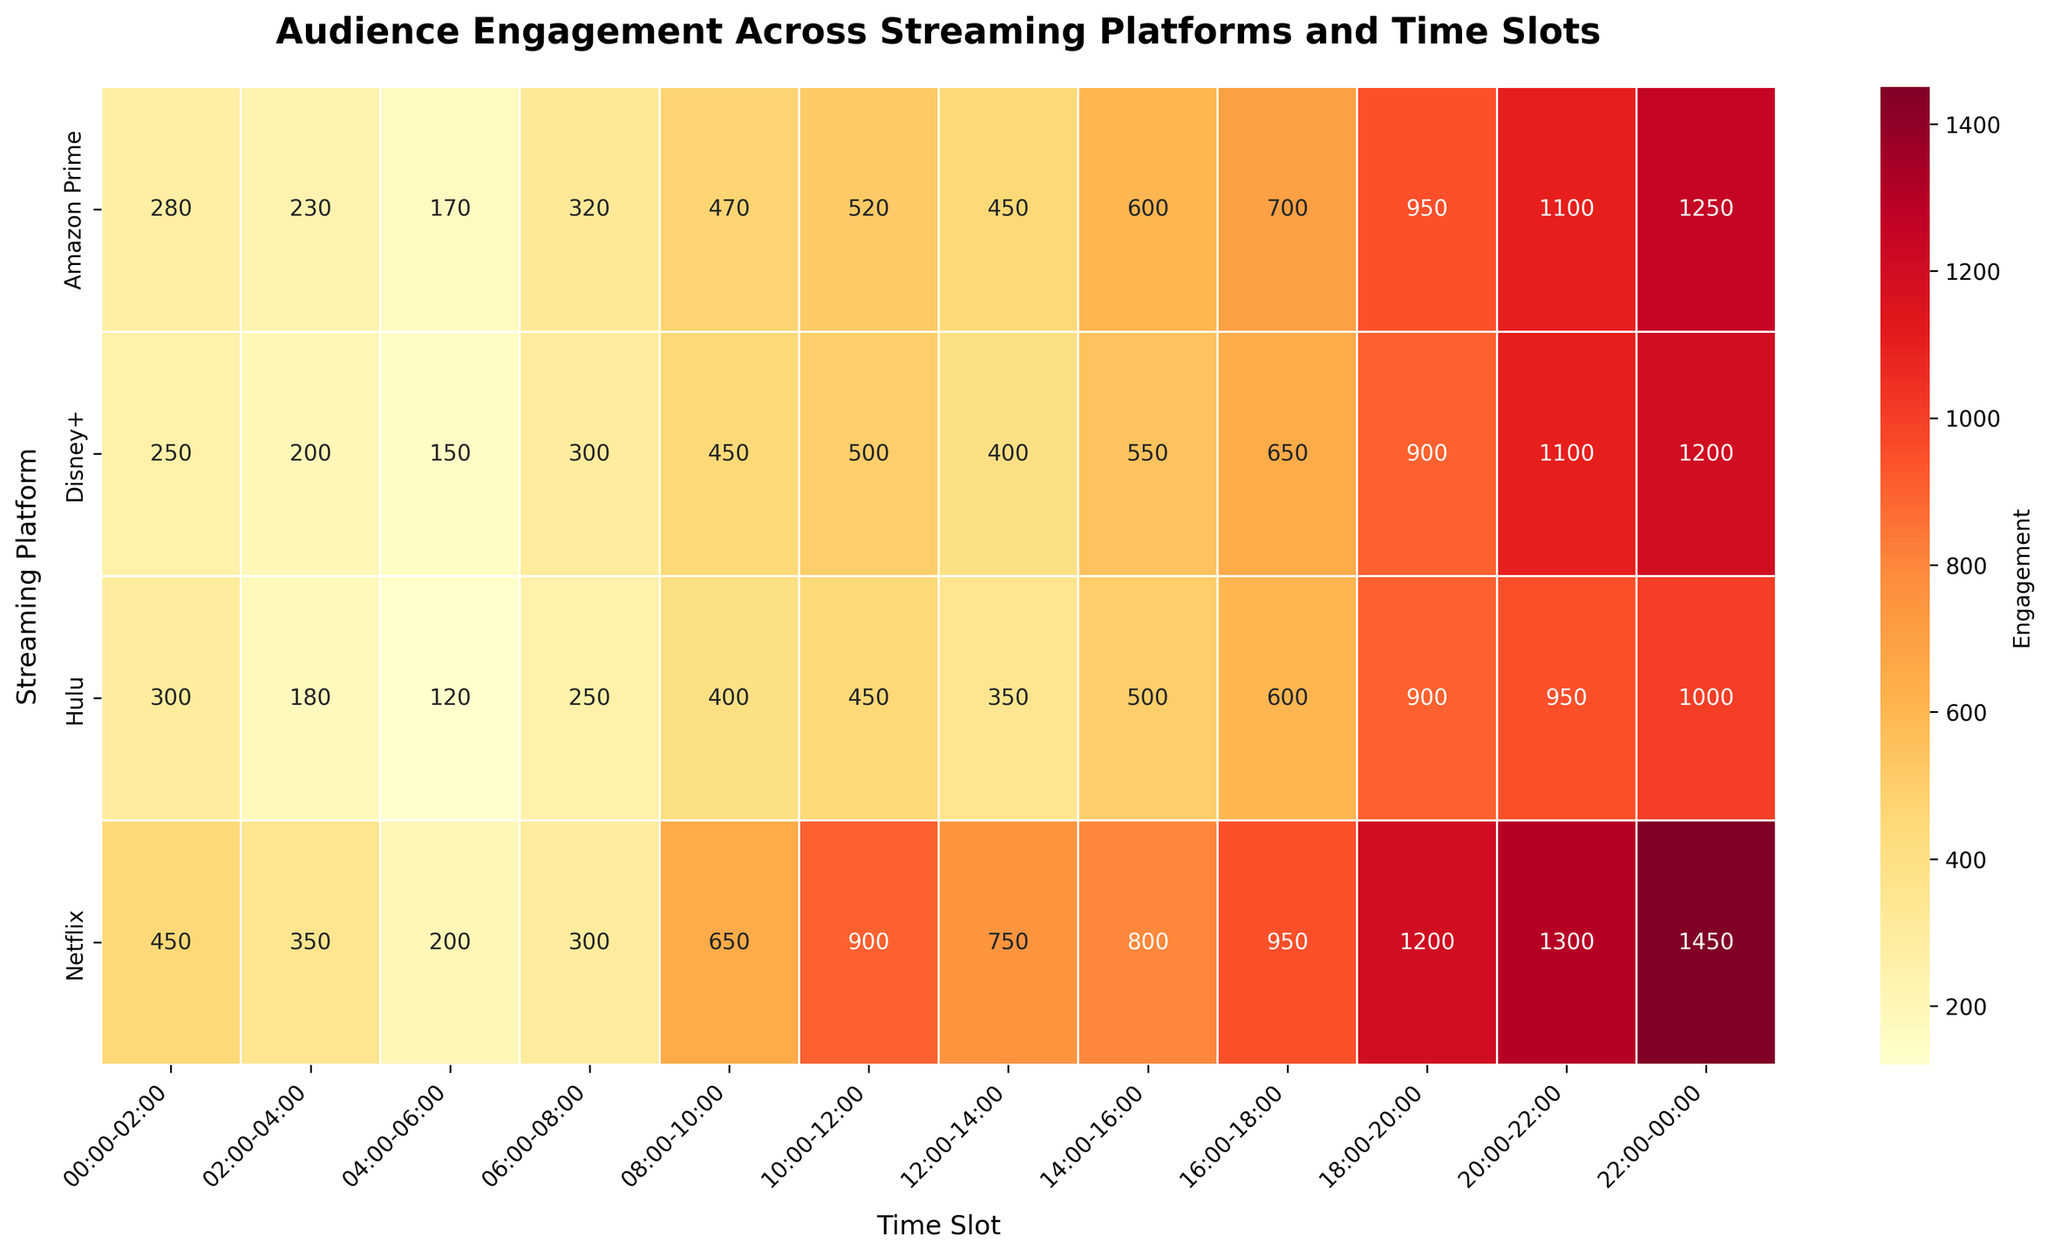Which time slot has the highest engagement for Netflix? Look at the row for Netflix and find the cell with the highest number.
Answer: 22:00-00:00 Which platform has the lowest engagement during the 04:00-06:00 time slot? Look at the 04:00-06:00 column and identify the platform with the smallest number.
Answer: Hulu What is the average engagement for all platforms during the 20:00-22:00 time slot? Add up the engagement values for all platforms in the 20:00-22:00 column (1300+950+1100+1100) and divide by 4. (1300+950+1100+1100)/4 = 1112.5
Answer: 1112.5 Compare the engagement between Hulu and Amazon Prime during the 16:00-18:00 time slot. Which has higher engagement? Look at the 16:00-18:00 column and compare Hulu's and Amazon Prime's values. Hulu has 600 and Amazon Prime has 700.
Answer: Amazon Prime Which platform has the most consistent engagement across different time slots? Look across all rows and visually assess which platform has the least variation in engagement values.
Answer: Amazon Prime What's the total engagement for Disney+ across all time slots? Add up all the engagement values in the Disney+ row. 250+200+150+300+450+500+400+550+650+900+1100+1200 = 6650
Answer: 6650 